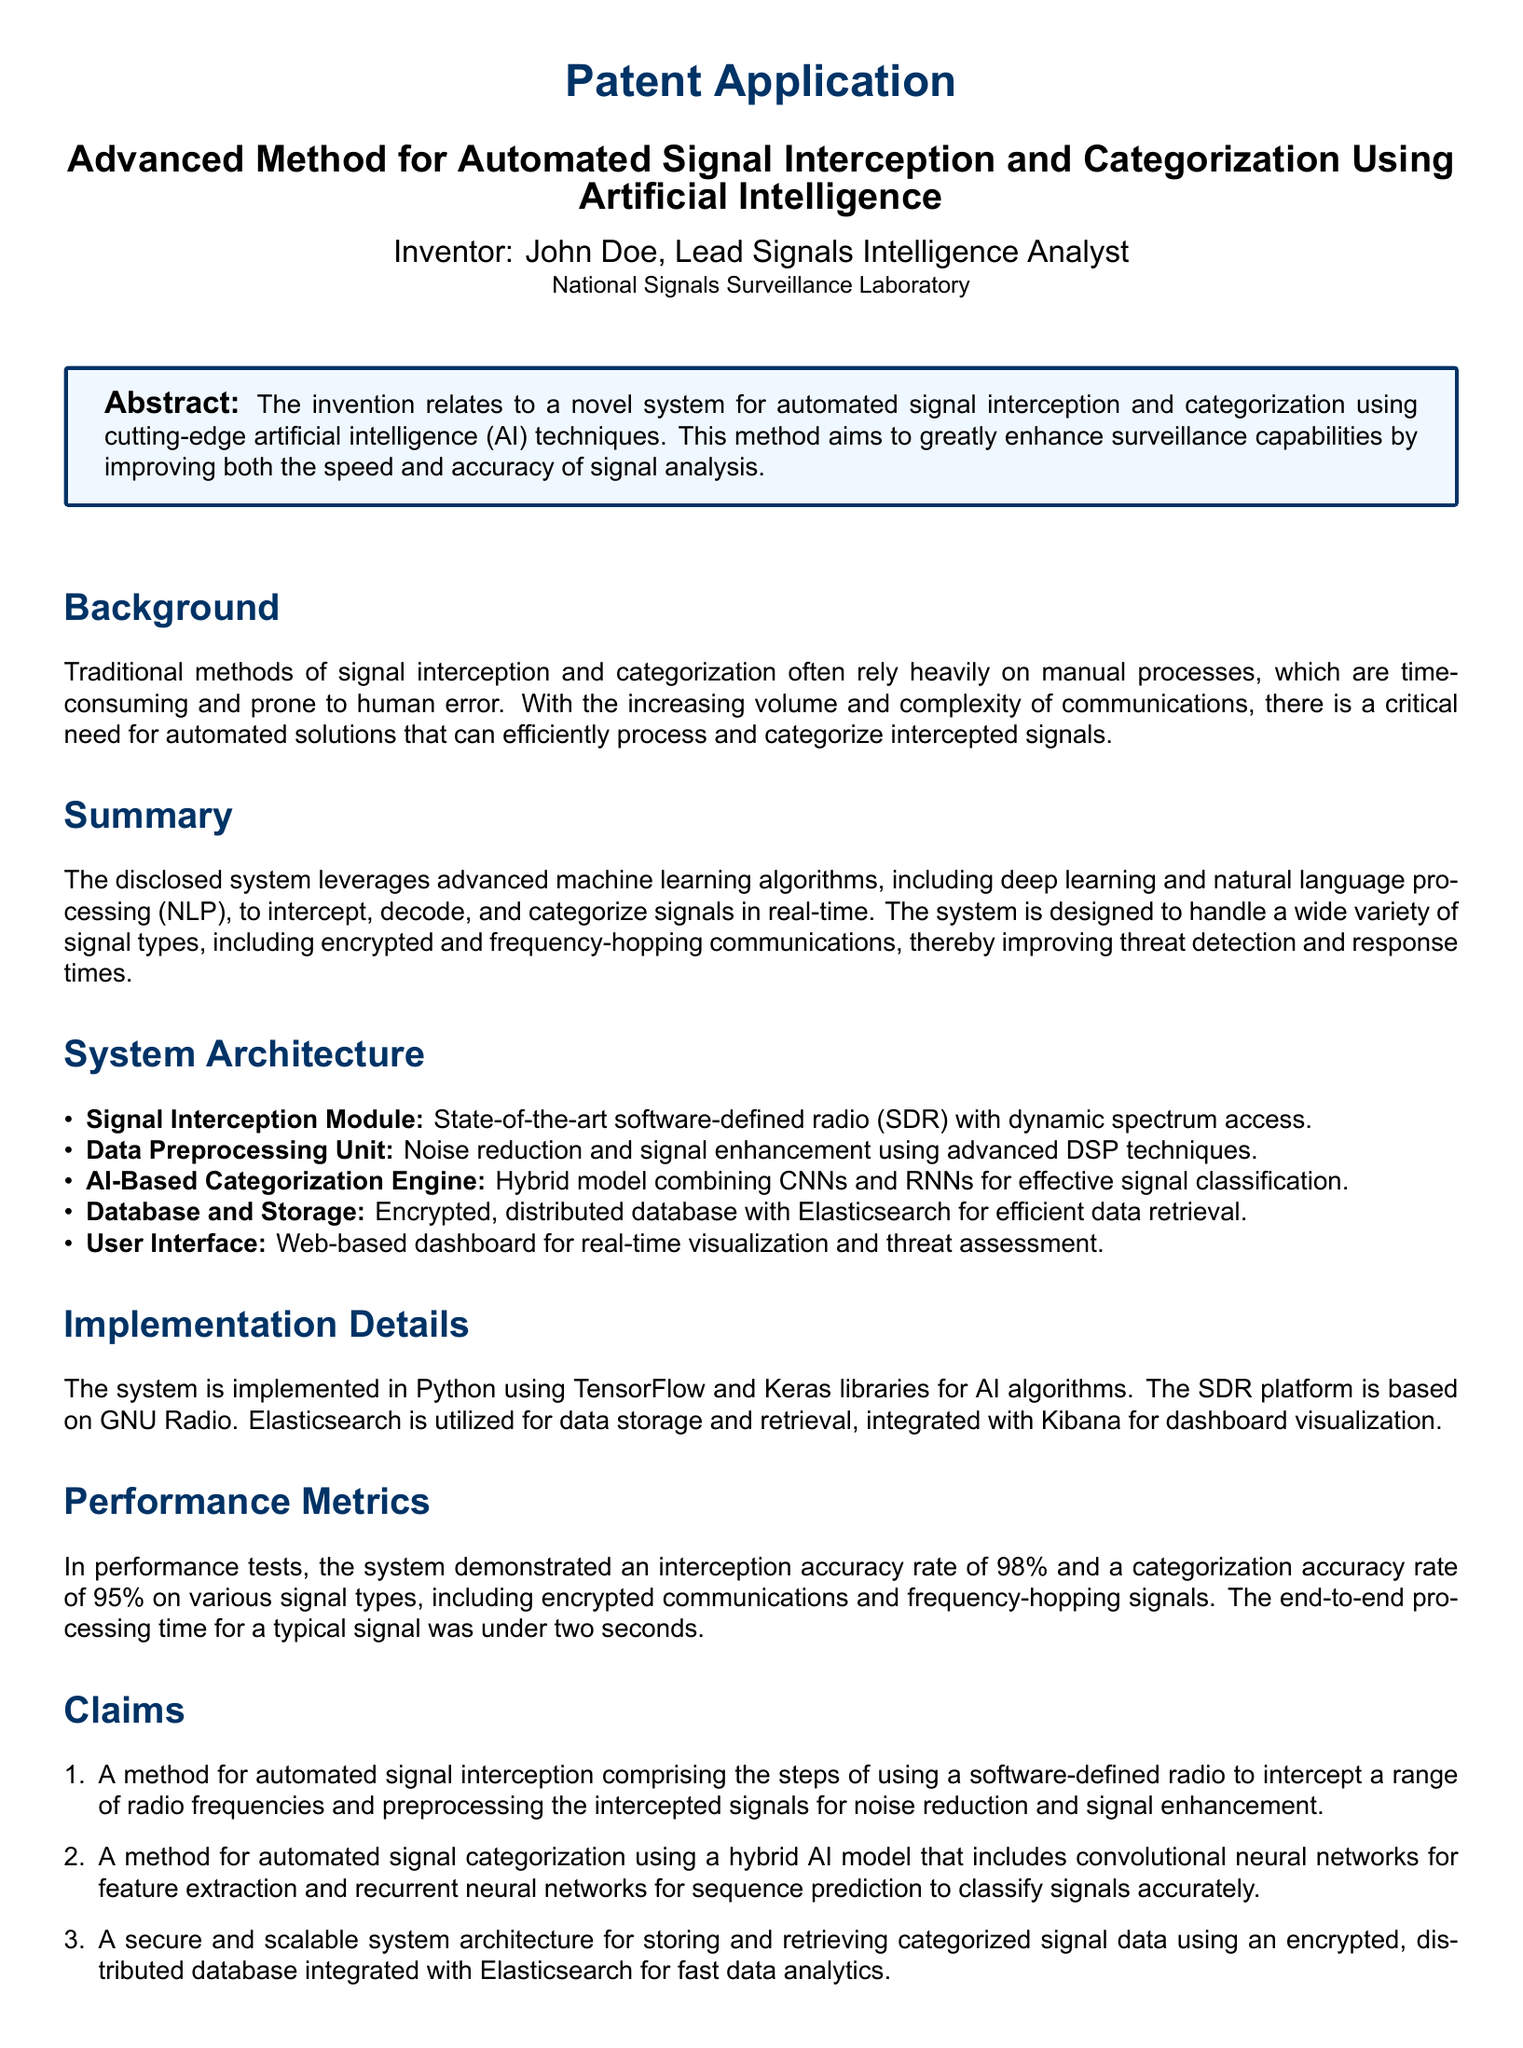What is the title of the invention? The title of the invention is specified in the document's header, detailing the patent application for an advanced method.
Answer: Advanced Method for Automated Signal Interception and Categorization Using Artificial Intelligence Who is the inventor? The inventor's name is mentioned prominently in the document, along with their title and organization.
Answer: John Doe What technology does the Signal Interception Module use? The document describes the technology used in the Signal Interception Module as state-of-the-art.
Answer: Software-defined radio What is the performance accuracy rate for interception? The document provides specific performance metrics, including accuracy rates for interception.
Answer: 98% What type of database is used for data storage? The document specifies the type of database implemented for data storage within the system architecture.
Answer: Encrypted, distributed database How does the AI-Based Categorization Engine classify signals? The document explains the method used by the AI-Based Categorization Engine for signal classification.
Answer: Hybrid model combining CNNs and RNNs How long does the end-to-end processing take for a typical signal? The processing time for a typical signal is noted in the performance metrics within the document.
Answer: Under two seconds What is the main purpose of the invention? The purpose of the invention is outlined in the abstract, summarizing its main objective.
Answer: Enhance surveillance capabilities What are the claims numbered in the document? The numbering of the claims is specified, indicating the structure of the legal assertions made for the patent.
Answer: Three 